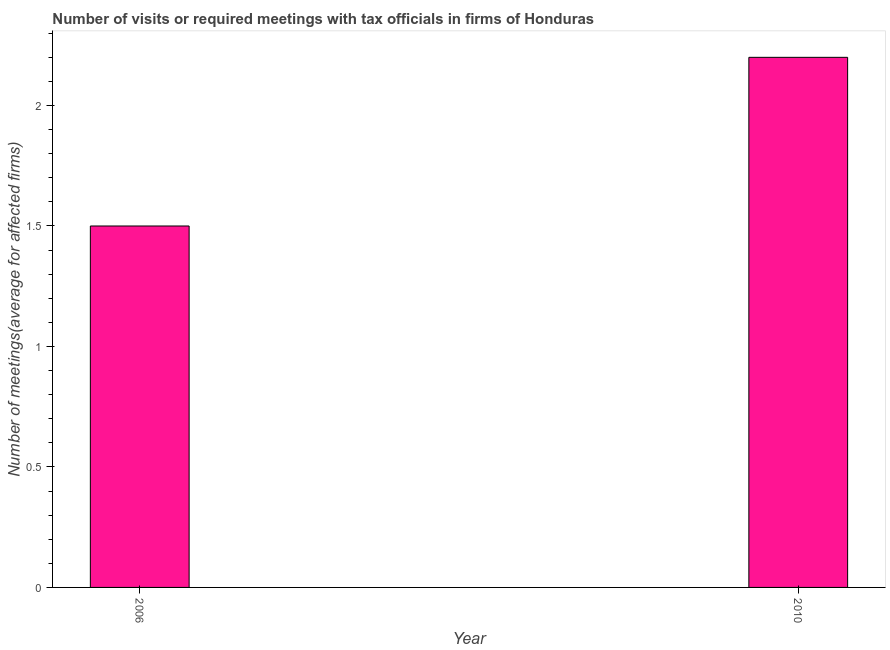What is the title of the graph?
Keep it short and to the point. Number of visits or required meetings with tax officials in firms of Honduras. What is the label or title of the X-axis?
Offer a very short reply. Year. What is the label or title of the Y-axis?
Give a very brief answer. Number of meetings(average for affected firms). What is the number of required meetings with tax officials in 2010?
Provide a succinct answer. 2.2. Across all years, what is the maximum number of required meetings with tax officials?
Give a very brief answer. 2.2. In which year was the number of required meetings with tax officials maximum?
Your answer should be compact. 2010. What is the sum of the number of required meetings with tax officials?
Offer a very short reply. 3.7. What is the average number of required meetings with tax officials per year?
Offer a terse response. 1.85. What is the median number of required meetings with tax officials?
Give a very brief answer. 1.85. What is the ratio of the number of required meetings with tax officials in 2006 to that in 2010?
Your answer should be compact. 0.68. In how many years, is the number of required meetings with tax officials greater than the average number of required meetings with tax officials taken over all years?
Offer a very short reply. 1. Are all the bars in the graph horizontal?
Ensure brevity in your answer.  No. How many years are there in the graph?
Provide a short and direct response. 2. What is the difference between two consecutive major ticks on the Y-axis?
Offer a very short reply. 0.5. Are the values on the major ticks of Y-axis written in scientific E-notation?
Offer a very short reply. No. What is the Number of meetings(average for affected firms) of 2010?
Your response must be concise. 2.2. What is the difference between the Number of meetings(average for affected firms) in 2006 and 2010?
Offer a terse response. -0.7. What is the ratio of the Number of meetings(average for affected firms) in 2006 to that in 2010?
Your response must be concise. 0.68. 